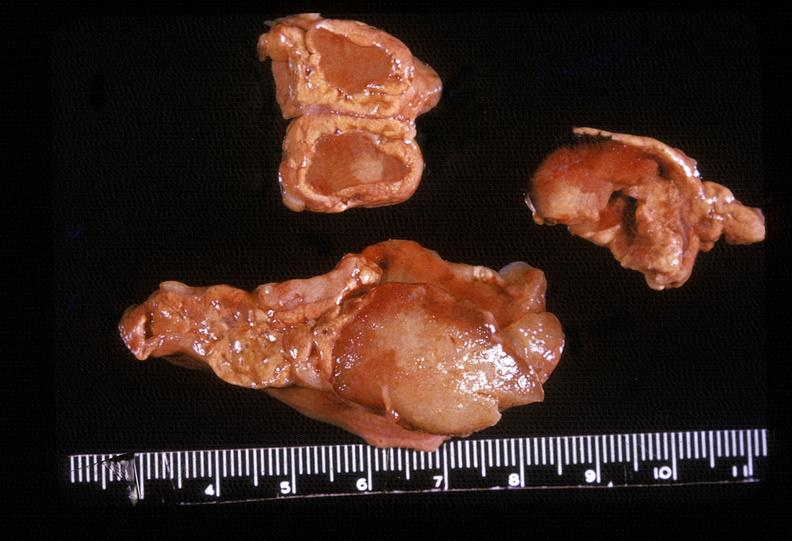does fat necrosis show adrenal, myelolipoma?
Answer the question using a single word or phrase. No 